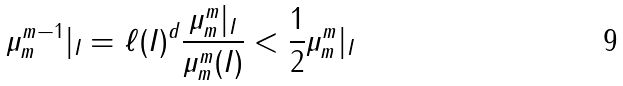<formula> <loc_0><loc_0><loc_500><loc_500>\mu _ { m } ^ { m - 1 } | _ { I } = \ell ( I ) ^ { d } \frac { \mu _ { m } ^ { m } | _ { I } } { \mu _ { m } ^ { m } ( I ) } < \frac { 1 } { 2 } \mu _ { m } ^ { m } | _ { I }</formula> 